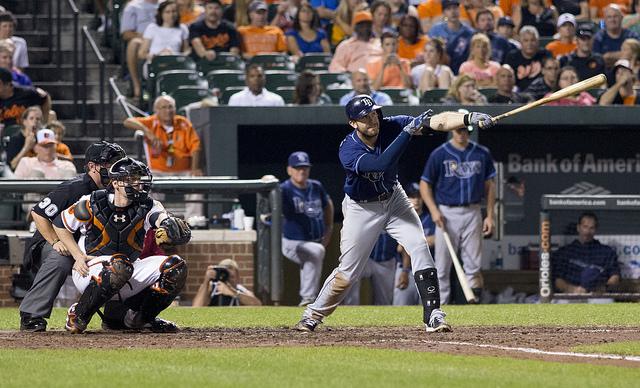What are the people in the bleachers watching?
Keep it brief. Baseball. Did the batter get a hit?
Short answer required. Yes. What sport is this?
Concise answer only. Baseball. What sport are the men playing?
Concise answer only. Baseball. 